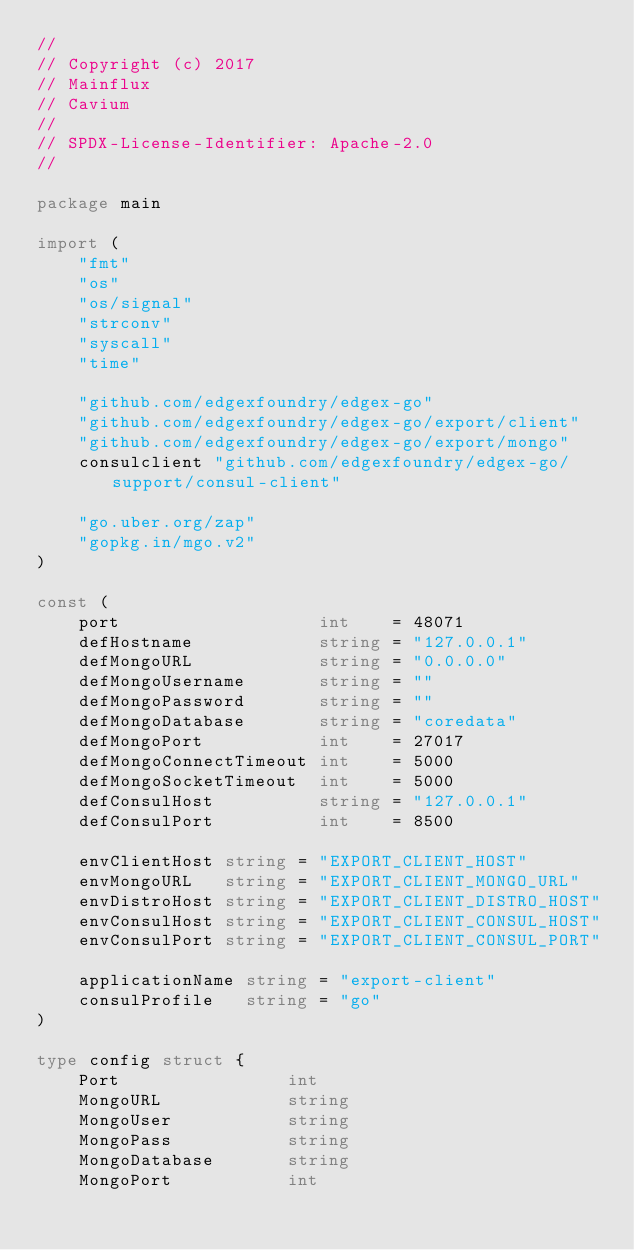<code> <loc_0><loc_0><loc_500><loc_500><_Go_>//
// Copyright (c) 2017
// Mainflux
// Cavium
//
// SPDX-License-Identifier: Apache-2.0
//

package main

import (
	"fmt"
	"os"
	"os/signal"
	"strconv"
	"syscall"
	"time"

	"github.com/edgexfoundry/edgex-go"
	"github.com/edgexfoundry/edgex-go/export/client"
	"github.com/edgexfoundry/edgex-go/export/mongo"
	consulclient "github.com/edgexfoundry/edgex-go/support/consul-client"

	"go.uber.org/zap"
	"gopkg.in/mgo.v2"
)

const (
	port                   int    = 48071
	defHostname            string = "127.0.0.1"
	defMongoURL            string = "0.0.0.0"
	defMongoUsername       string = ""
	defMongoPassword       string = ""
	defMongoDatabase       string = "coredata"
	defMongoPort           int    = 27017
	defMongoConnectTimeout int    = 5000
	defMongoSocketTimeout  int    = 5000
	defConsulHost          string = "127.0.0.1"
	defConsulPort          int    = 8500

	envClientHost string = "EXPORT_CLIENT_HOST"
	envMongoURL   string = "EXPORT_CLIENT_MONGO_URL"
	envDistroHost string = "EXPORT_CLIENT_DISTRO_HOST"
	envConsulHost string = "EXPORT_CLIENT_CONSUL_HOST"
	envConsulPort string = "EXPORT_CLIENT_CONSUL_PORT"

	applicationName string = "export-client"
	consulProfile   string = "go"
)

type config struct {
	Port                int
	MongoURL            string
	MongoUser           string
	MongoPass           string
	MongoDatabase       string
	MongoPort           int</code> 